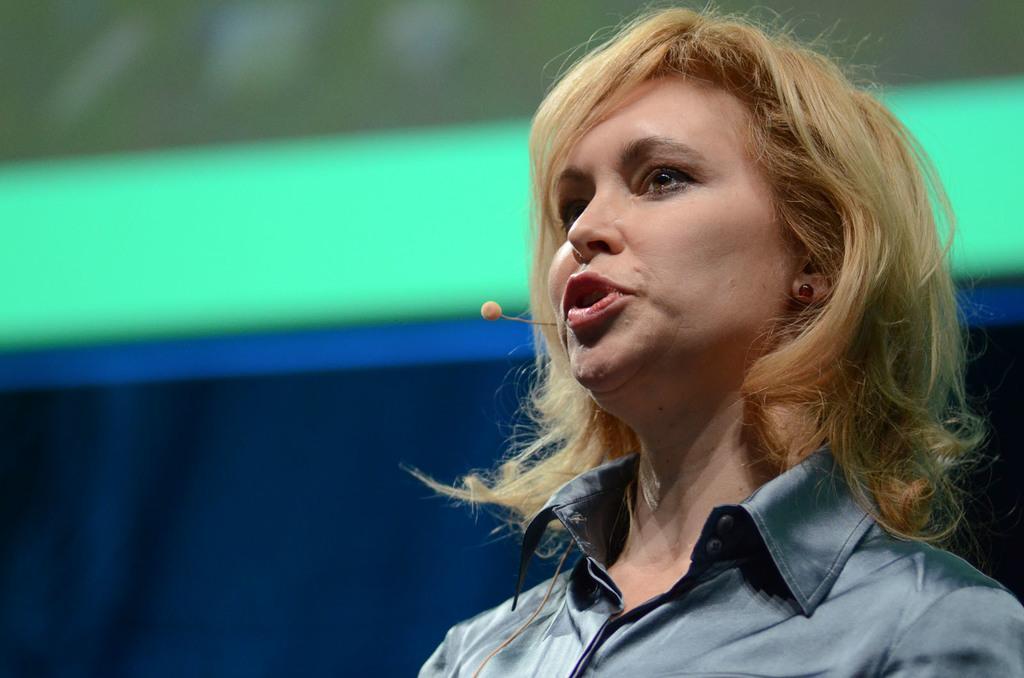Please provide a concise description of this image. In this image I can see the person. Background is in blue, white and green color. 